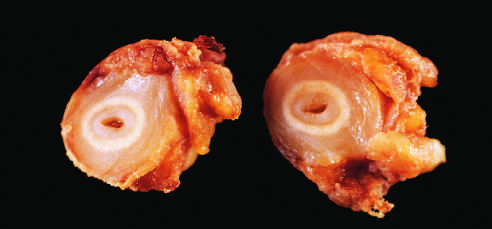what do the white circles correspond to?
Answer the question using a single word or phrase. The original vessel wall 